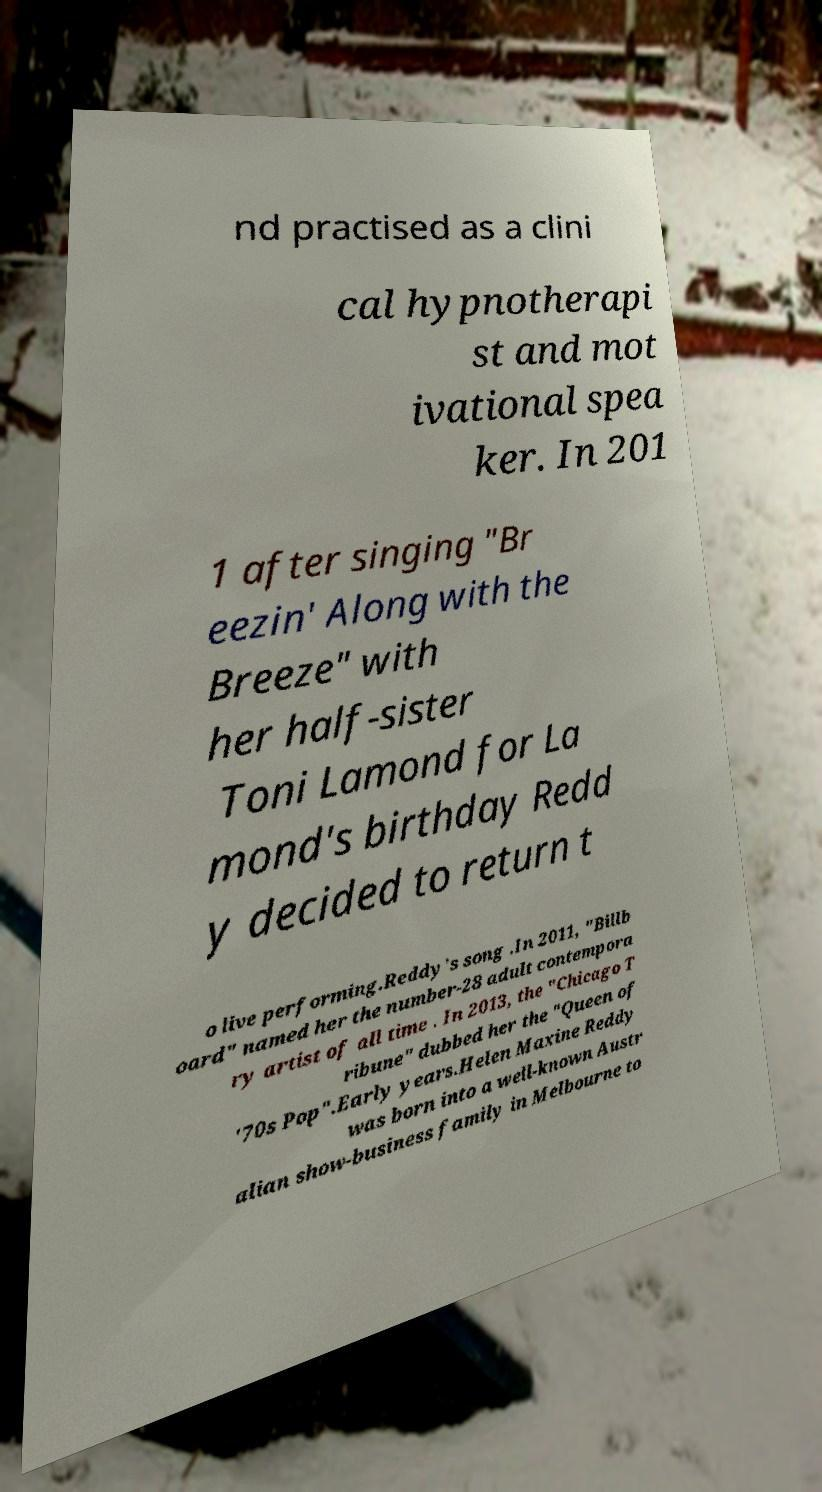Can you accurately transcribe the text from the provided image for me? nd practised as a clini cal hypnotherapi st and mot ivational spea ker. In 201 1 after singing "Br eezin' Along with the Breeze" with her half-sister Toni Lamond for La mond's birthday Redd y decided to return t o live performing.Reddy's song .In 2011, "Billb oard" named her the number-28 adult contempora ry artist of all time . In 2013, the "Chicago T ribune" dubbed her the "Queen of '70s Pop".Early years.Helen Maxine Reddy was born into a well-known Austr alian show-business family in Melbourne to 